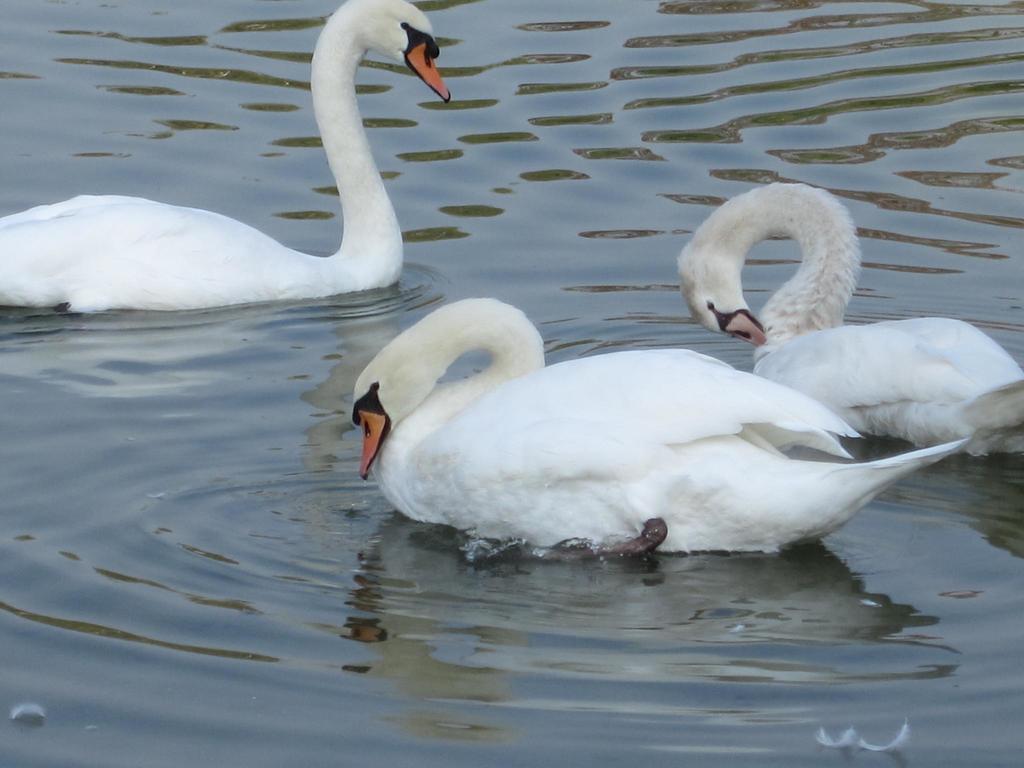Could you give a brief overview of what you see in this image? In the center of the image we can see three swans. In the background of the image we can see the water. 